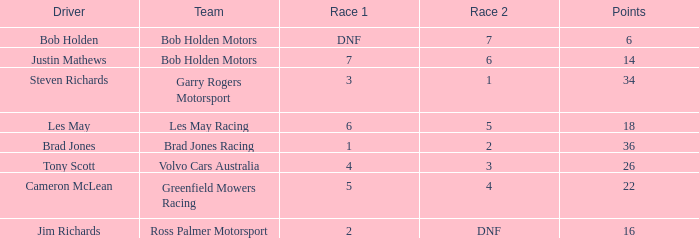Which driver for Bob Holden Motors has fewer than 36 points and placed 7 in race 1? Justin Mathews. 